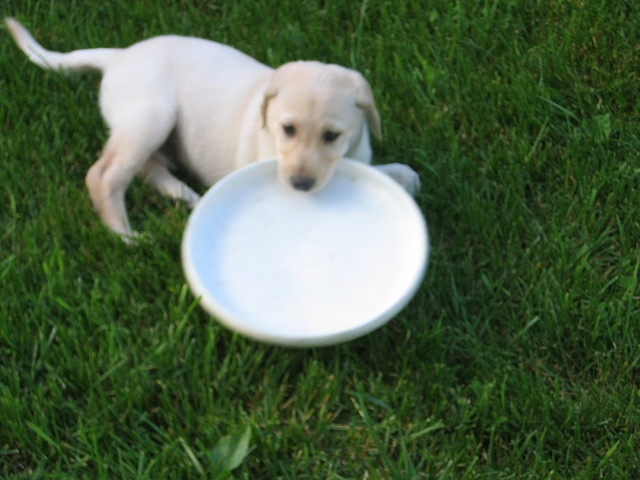Describe the objects in this image and their specific colors. I can see dog in darkgreen, lightgray, darkgray, and gray tones and frisbee in darkgreen, white, lightblue, darkgray, and black tones in this image. 